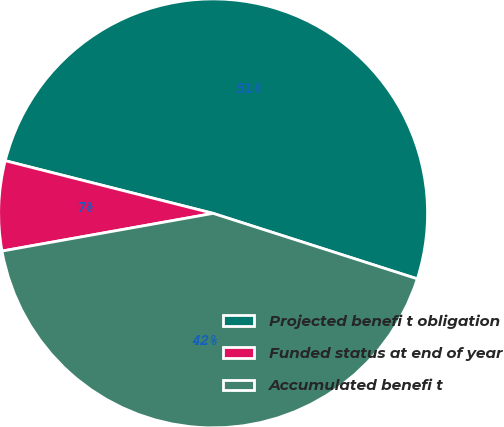<chart> <loc_0><loc_0><loc_500><loc_500><pie_chart><fcel>Projected benefi t obligation<fcel>Funded status at end of year<fcel>Accumulated benefi t<nl><fcel>50.99%<fcel>6.76%<fcel>42.25%<nl></chart> 